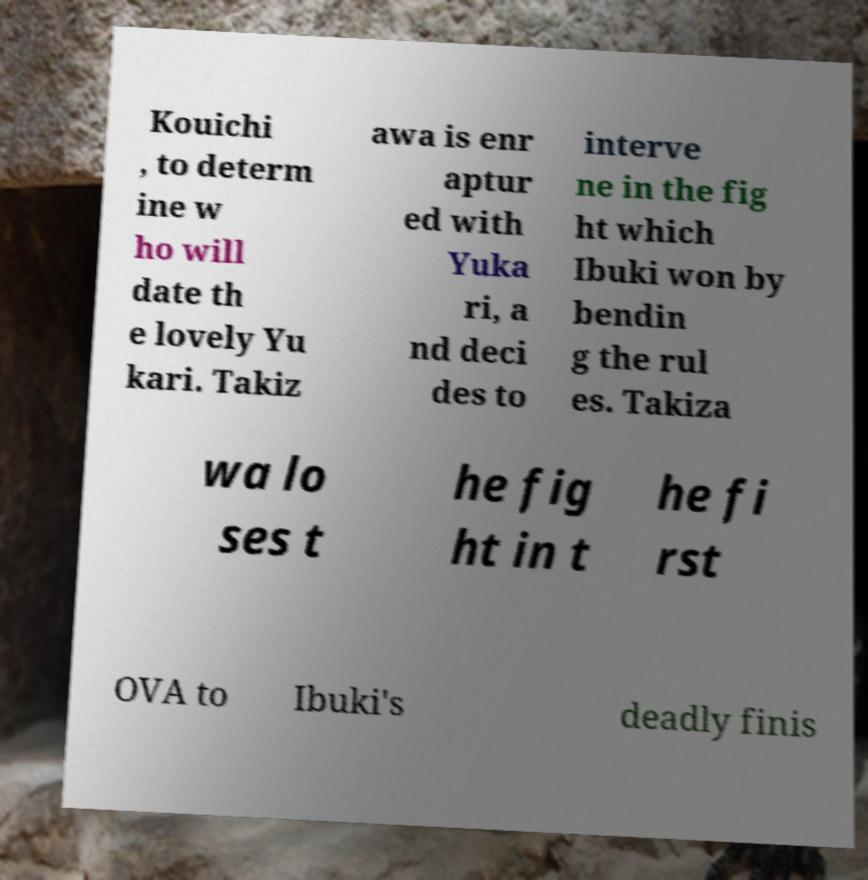There's text embedded in this image that I need extracted. Can you transcribe it verbatim? Kouichi , to determ ine w ho will date th e lovely Yu kari. Takiz awa is enr aptur ed with Yuka ri, a nd deci des to interve ne in the fig ht which Ibuki won by bendin g the rul es. Takiza wa lo ses t he fig ht in t he fi rst OVA to Ibuki's deadly finis 